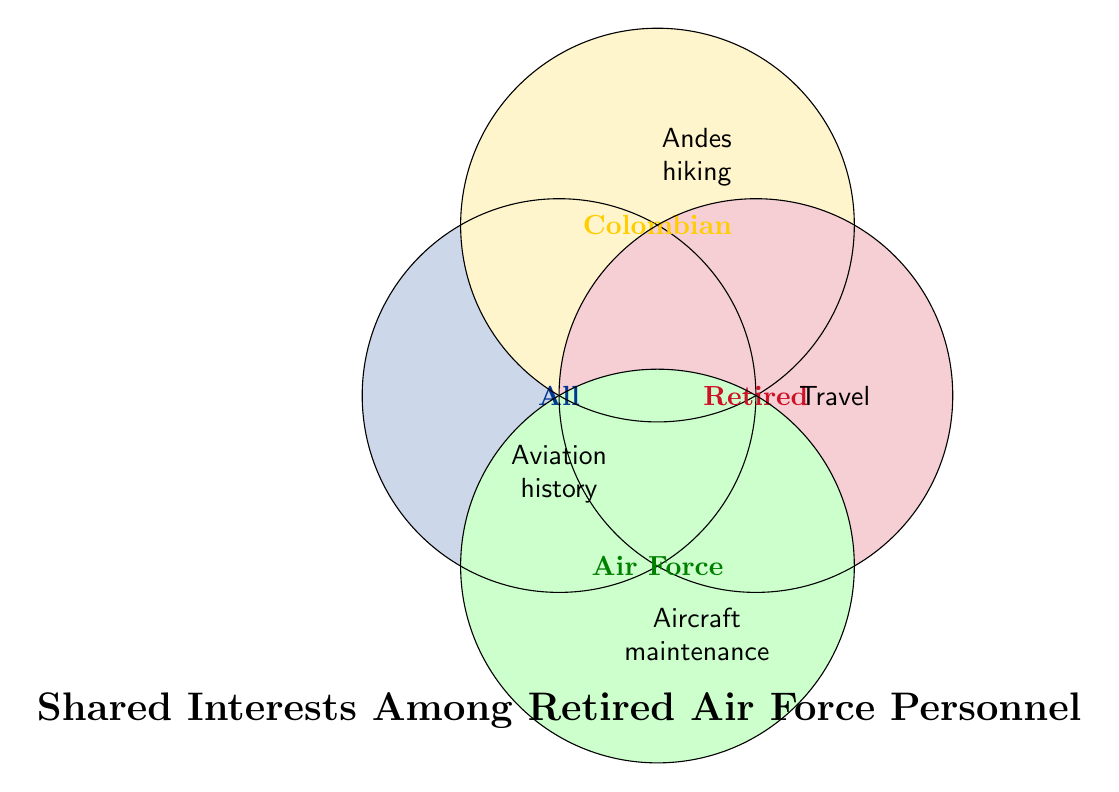What is the title of the figure? The title of the figure is presented at the bottom in bold font and provides a summary of the diagram's content. The title states "Shared Interests Among Retired Air Force Personnel."
Answer: Shared Interests Among Retired Air Force Personnel What interest is shared by all categories? The interest centrally located and overlapping all circles is "Aviation history," indicating it is common to all categories.
Answer: Aviation history Which interest is exclusively related to the Colombian category? The interest specifically in the Colombian circle and not overlapping with others is "Andes mountain hiking."
Answer: Andes mountain hiking How many interests are related to the Retired category? By observing the Retired circle, the interests listed are "Grandchildren," "Travel," and "Gardening," indicating a total of three interests.
Answer: Three Which category includes the interest "Aircraft maintenance"? The interest "Aircraft maintenance" is within the Air Force circle area.
Answer: Air Force What are the shared interests between the Retired and Air Force categories? To find shared interests, check for overlaps between the Retired and Air Force circles. "Aviation history" is a shared interest as it lies within all circles, including these two.
Answer: Aviation history Which interest is common to the Colombian and Retired categories? Locate the overlap between the Colombian and Retired circles. The shared interest is "Travel" as it is positioned between these two circles.
Answer: Travel What colors represent the Colombian and Retired categories? The Colombian category is denoted by a yellow color, and the Retired category is represented by a red color.
Answer: Colombian: Yellow, Retired: Red What is the unique interest related to the Air Force category? The unique interest within the Air Force circle and not shared with any other category is "Flight simulation."
Answer: Flight simulation 